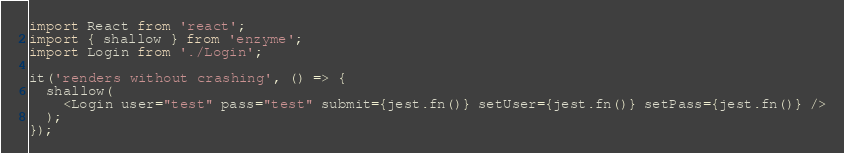Convert code to text. <code><loc_0><loc_0><loc_500><loc_500><_TypeScript_>import React from 'react';
import { shallow } from 'enzyme';
import Login from './Login';

it('renders without crashing', () => {
  shallow(
    <Login user="test" pass="test" submit={jest.fn()} setUser={jest.fn()} setPass={jest.fn()} />
  );
});
</code> 